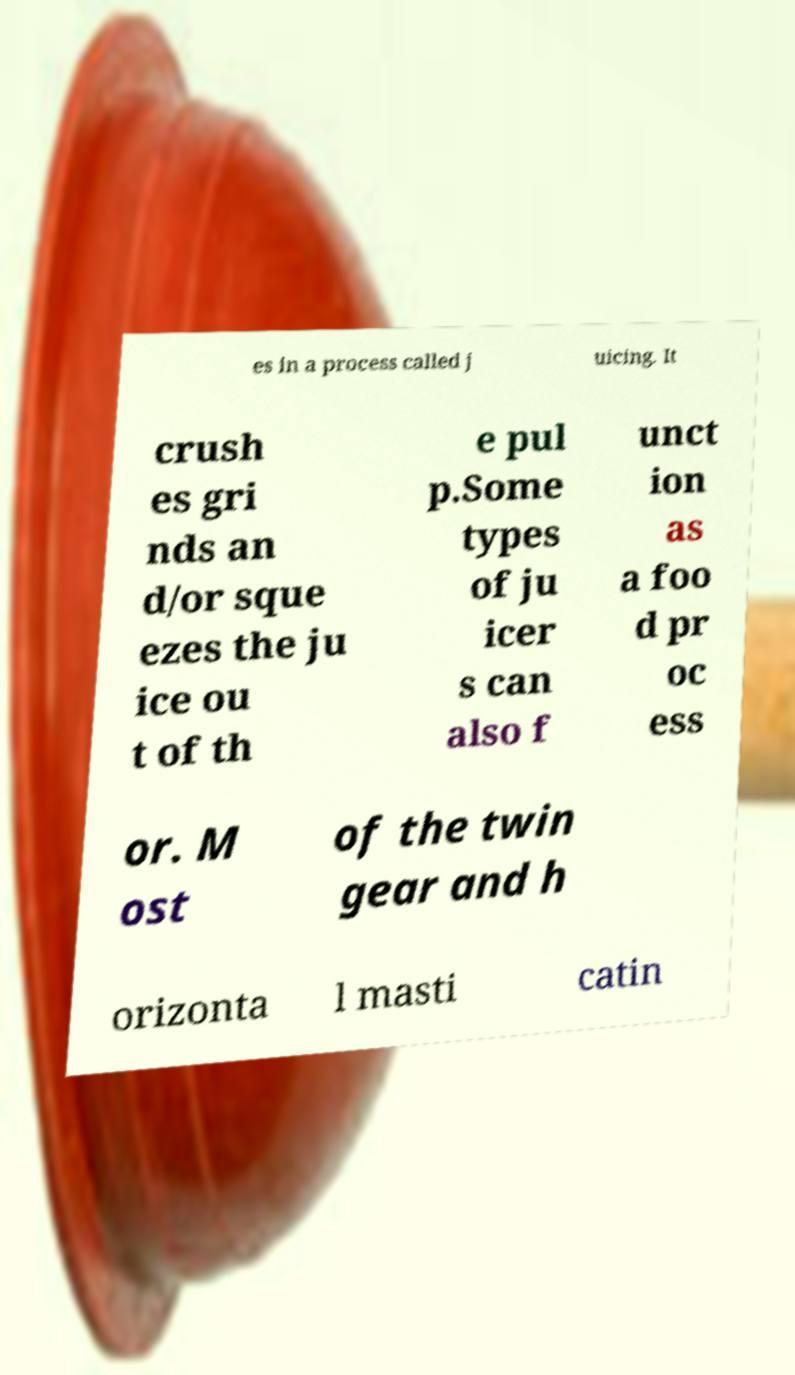I need the written content from this picture converted into text. Can you do that? es in a process called j uicing. It crush es gri nds an d/or sque ezes the ju ice ou t of th e pul p.Some types of ju icer s can also f unct ion as a foo d pr oc ess or. M ost of the twin gear and h orizonta l masti catin 